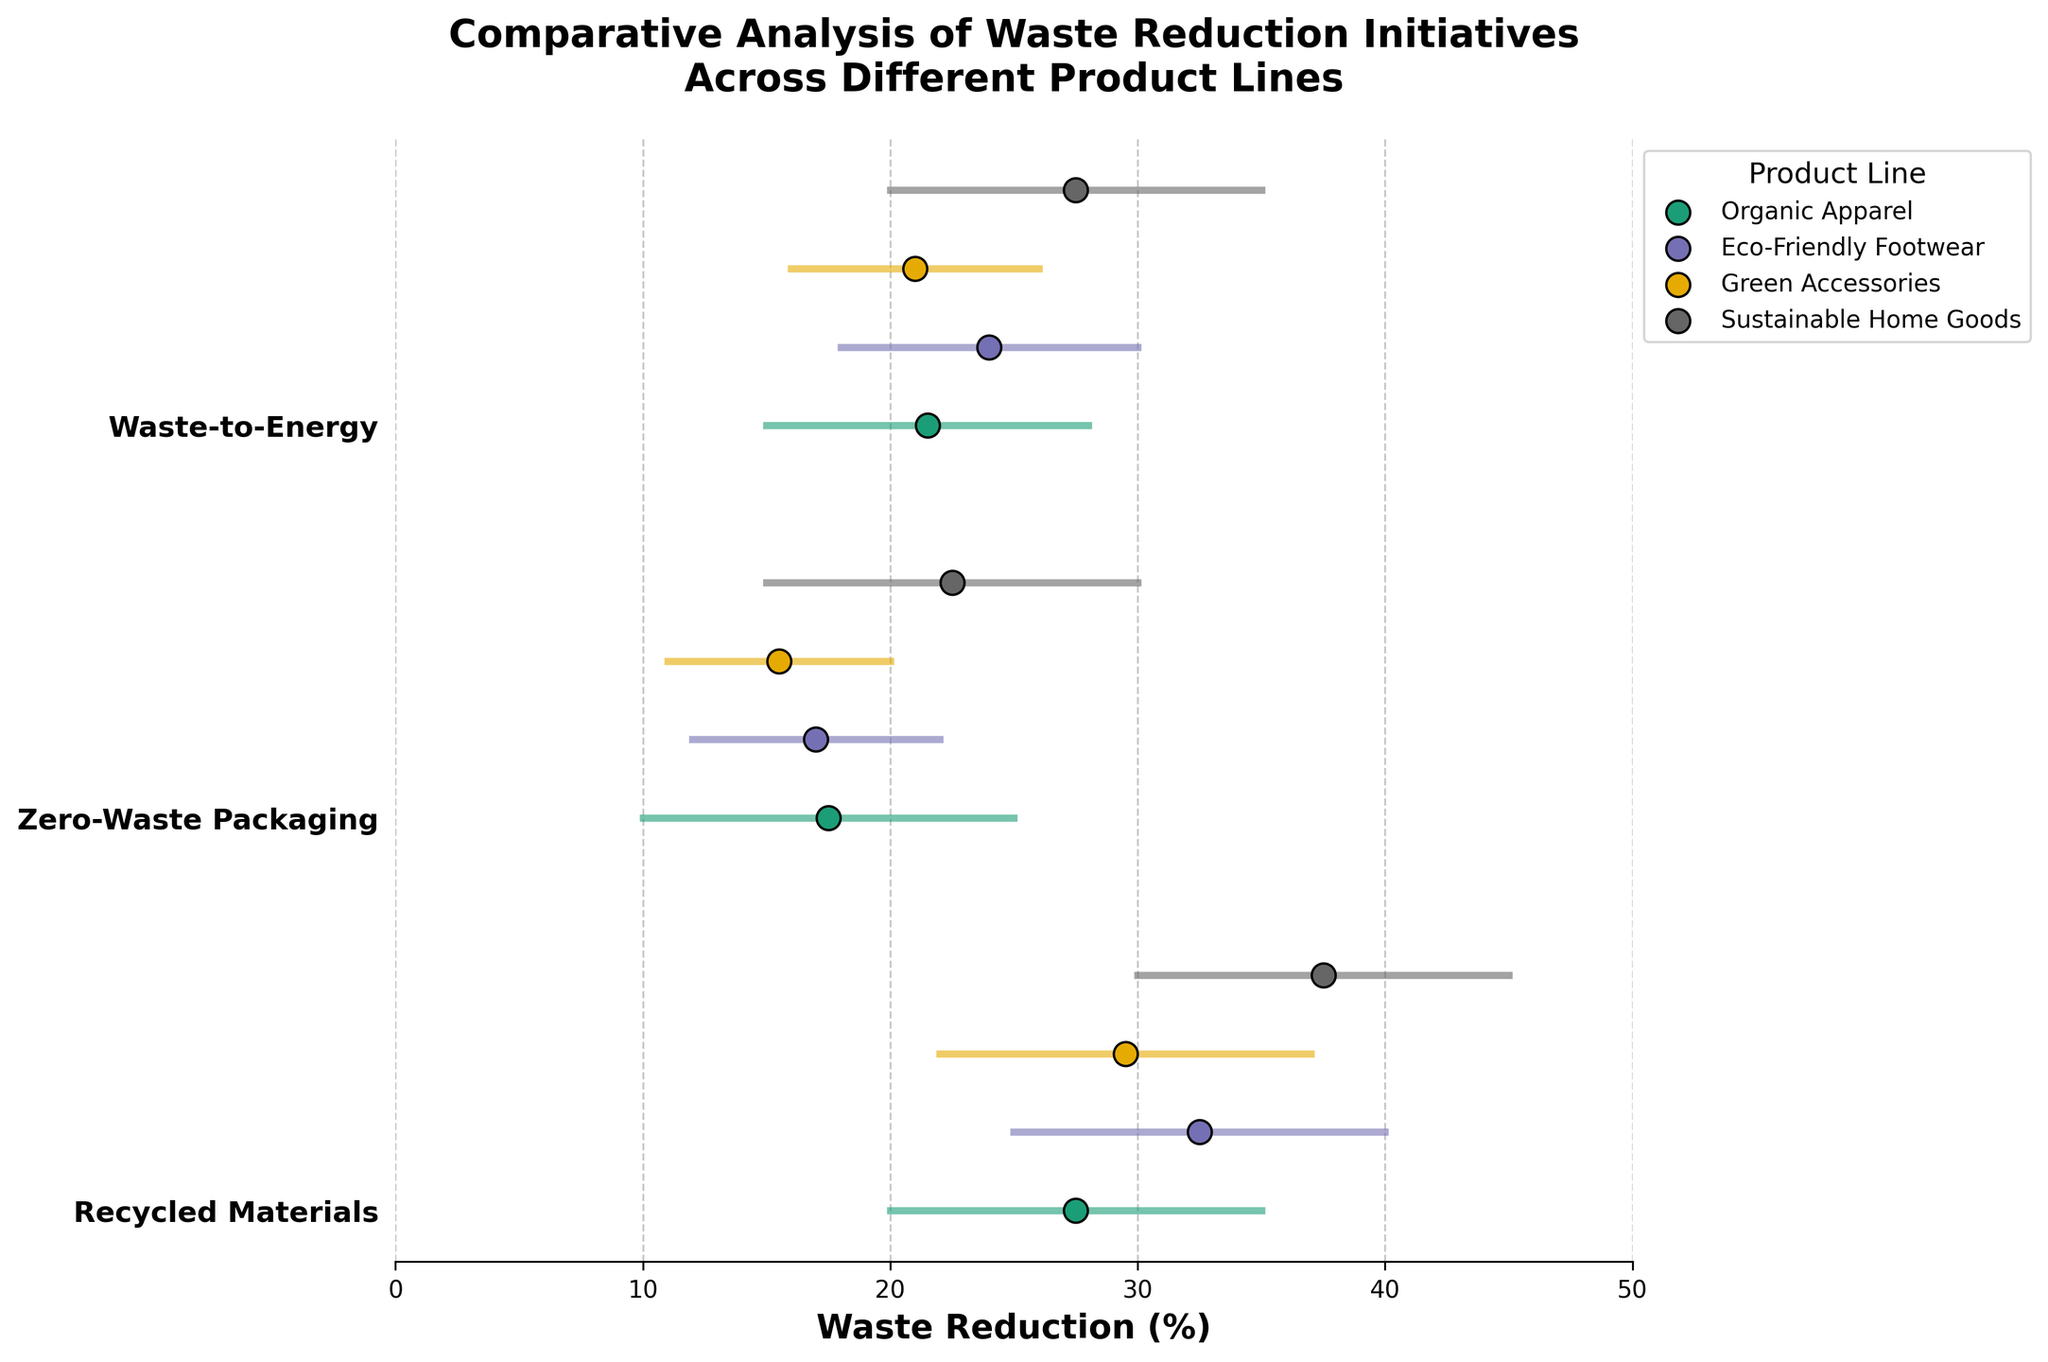What is the maximum waste reduction percentage achieved by Sustainable Home Goods using Recycled Materials? Look for the maximum percentage value in the Recycled Materials category for Sustainable Home Goods. The data indicates it is 45%.
Answer: 45% Which product line shows the greatest range in waste reduction for Zero-Waste Packaging? Compare the range (max - min reduction) for Zero-Waste Packaging across the product lines. Sustainable Home Goods has the greatest range of 15% (30 - 15).
Answer: Sustainable Home Goods What is the average waste reduction range for the Waste-to-Energy initiative across all product lines? Calculate the range for each product line in the Waste-to-Energy category and then find the average of these ranges. Ranges: Organic Apparel (28-15=13), Eco-Friendly Footwear (30-18=12), Green Accessories (26-16=10), Sustainable Home Goods (35-20=15). The average range is (13+12+10+15)/4 = 12.5%.
Answer: 12.5% Which product line consistently shows the highest minimum waste reduction percentage across all initiatives? Compare the minimum waste reduction percentages for each initiative across all product lines. Sustainable Home Goods has the highest minimum percentages: Recycled Materials (30%), Zero-Waste Packaging (15%), Waste-to-Energy (20%).
Answer: Sustainable Home Goods In the Recycled Materials initiative, which product line has the smallest waste reduction range? Calculate the waste reduction range for Recycled Materials in each product line: Organic Apparel (35-20=15), Eco-Friendly Footwear (40-25=15), Green Accessories (37-22=15), Sustainable Home Goods (45-30=15). All ranges are 15%. However, if interpreted as asking for actual smallest reduction, all lines have the same. Hence, no single product line has the smallest range.
Answer: All same 